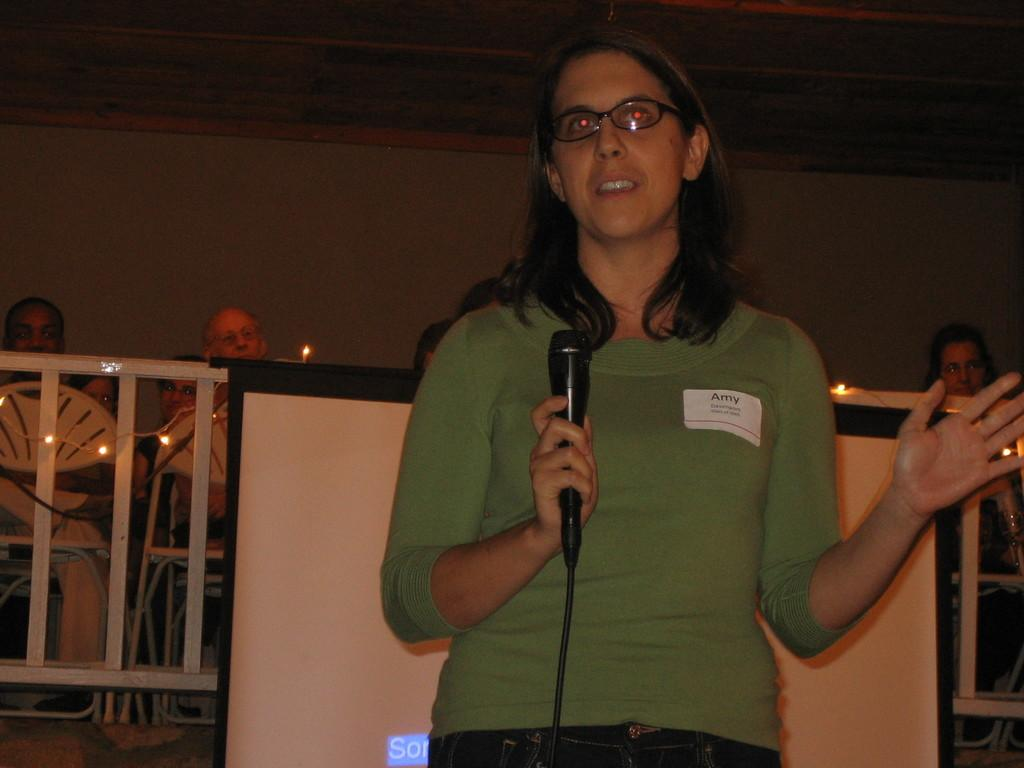Who is the main subject in the image? There is a woman in the image. What is the woman wearing? The woman is wearing a t-shirt and trousers. Can you describe the woman's hairstyle? The woman has short hair. What is the woman holding in the image? The woman is holding a microphone. What can be seen in the background of the image? There are people, light, and a screen present in the background. What type of feast is being prepared in the image? There is no feast being prepared in the image; it features a woman holding a microphone. What mathematical operation is being performed on the vein in the image? There is no vein or mathematical operation present in the image. 